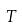<formula> <loc_0><loc_0><loc_500><loc_500>T</formula> 